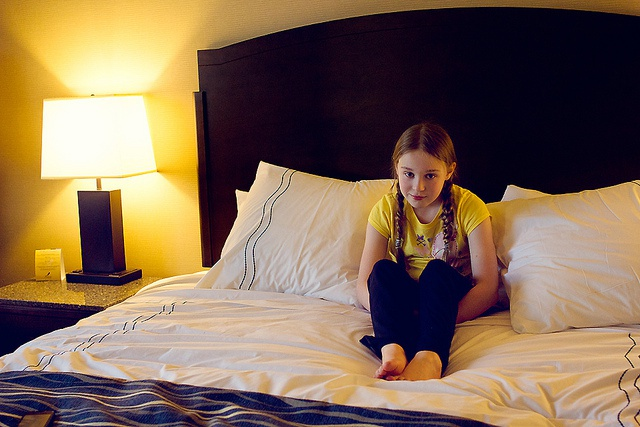Describe the objects in this image and their specific colors. I can see bed in black, olive, tan, and darkgray tones and people in olive, navy, brown, and maroon tones in this image. 